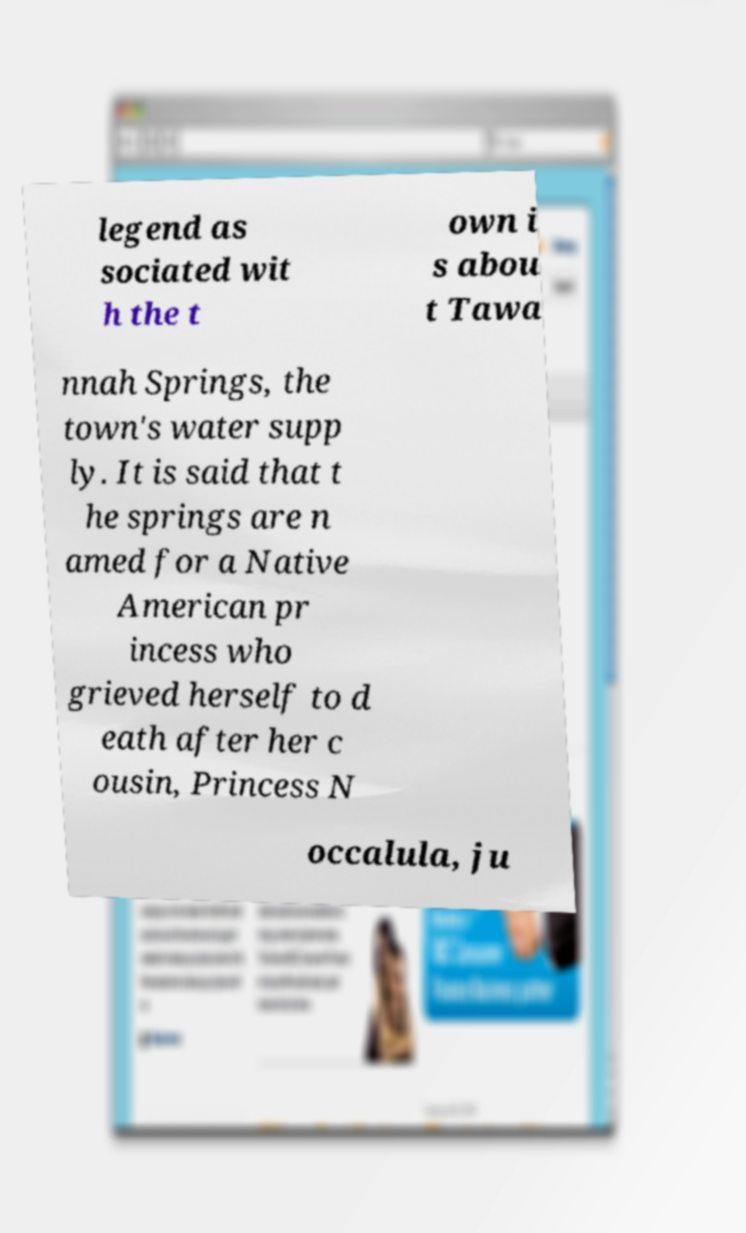I need the written content from this picture converted into text. Can you do that? legend as sociated wit h the t own i s abou t Tawa nnah Springs, the town's water supp ly. It is said that t he springs are n amed for a Native American pr incess who grieved herself to d eath after her c ousin, Princess N occalula, ju 